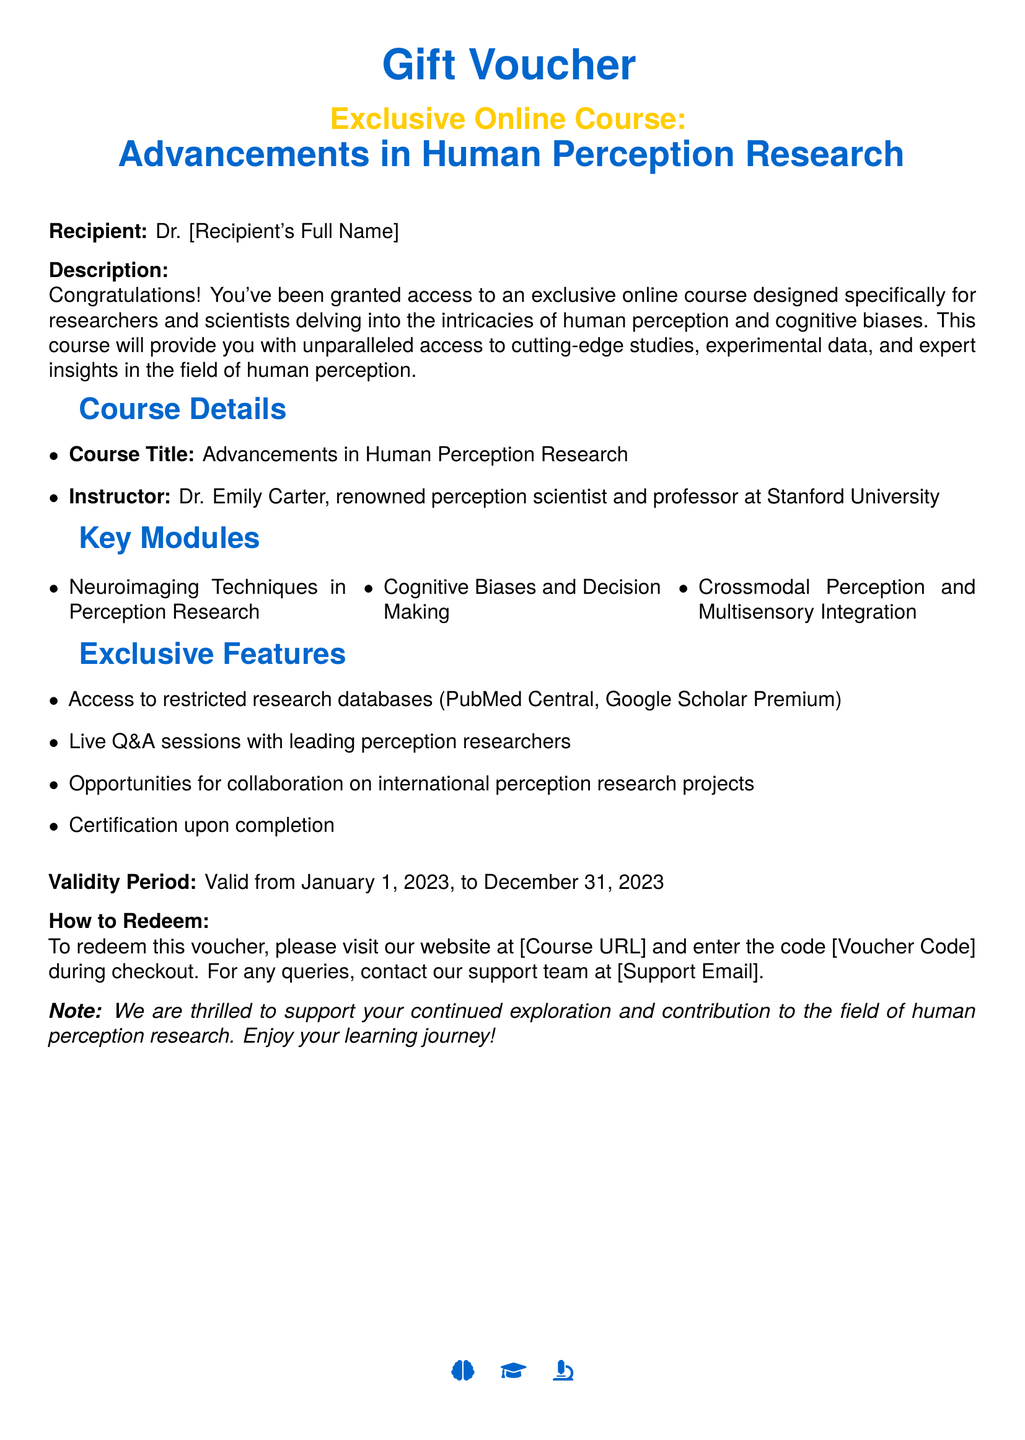What is the course title? The course title is explicitly stated in the document as "Advancements in Human Perception Research."
Answer: Advancements in Human Perception Research Who is the instructor? The document specifies that the instructor is Dr. Emily Carter, a renowned perception scientist and professor at Stanford University.
Answer: Dr. Emily Carter What is the validity period of the voucher? The document mentions the validity period as starting from January 1, 2023, to December 31, 2023.
Answer: January 1, 2023, to December 31, 2023 What are the key modules covered in the course? The key modules include Neuroimaging Techniques in Perception Research, Cognitive Biases and Decision Making, and Crossmodal Perception and Multisensory Integration.
Answer: Neuroimaging Techniques in Perception Research, Cognitive Biases and Decision Making, Crossmodal Perception and Multisensory Integration How can the voucher be redeemed? The document states that to redeem the voucher, one must visit the specified website and enter the voucher code during checkout.
Answer: Visit our website and enter the code during checkout What is the unique feature of the course? The document lists several exclusive features, including access to restricted research databases, live Q&A sessions, and certification upon completion.
Answer: Access to restricted research databases What does the recipient receive upon completion? According to the document, the recipient receives certification upon completion of the course.
Answer: Certification upon completion What is the purpose of this gift voucher? The purpose is to grant access to an exclusive online course designed specifically for researchers and scientists in human perception and cognitive biases.
Answer: Access to an exclusive online course 